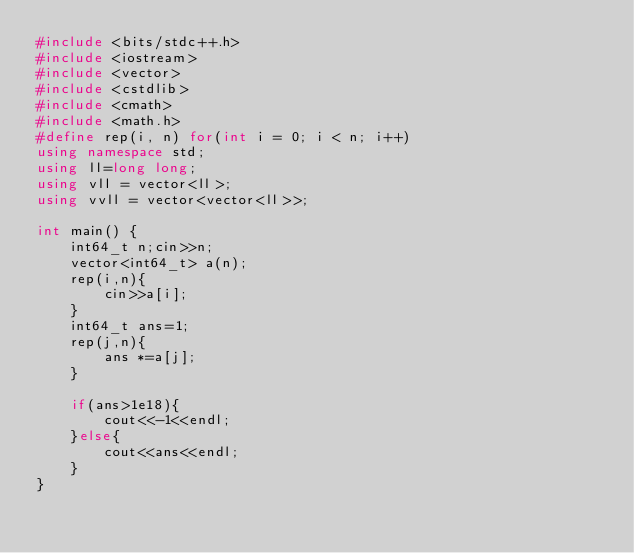<code> <loc_0><loc_0><loc_500><loc_500><_C++_>#include <bits/stdc++.h>
#include <iostream>
#include <vector>
#include <cstdlib>
#include <cmath>
#include <math.h>
#define rep(i, n) for(int i = 0; i < n; i++)
using namespace std;
using ll=long long;
using vll = vector<ll>;
using vvll = vector<vector<ll>>;

int main() {
    int64_t n;cin>>n;
    vector<int64_t> a(n);
    rep(i,n){
        cin>>a[i];
    }
    int64_t ans=1;
    rep(j,n){
        ans *=a[j];
    }

    if(ans>1e18){
        cout<<-1<<endl;
    }else{
        cout<<ans<<endl;
    }
}</code> 